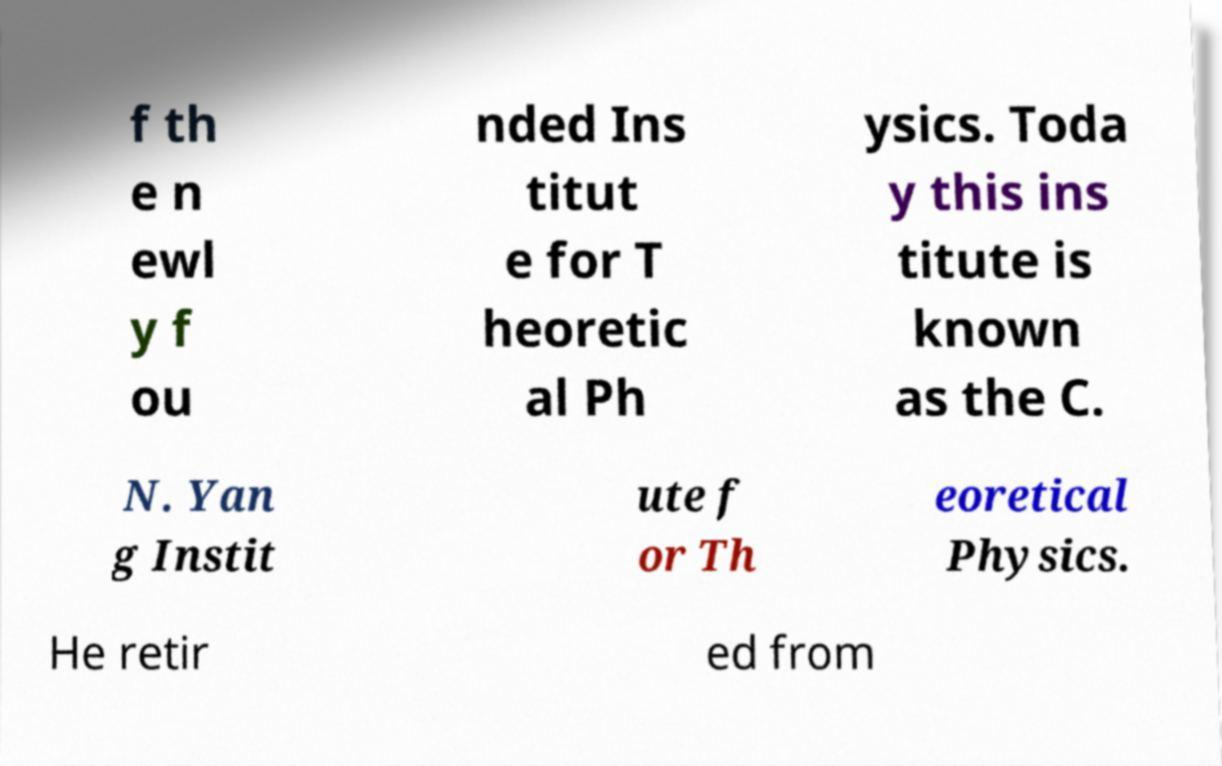Could you assist in decoding the text presented in this image and type it out clearly? f th e n ewl y f ou nded Ins titut e for T heoretic al Ph ysics. Toda y this ins titute is known as the C. N. Yan g Instit ute f or Th eoretical Physics. He retir ed from 